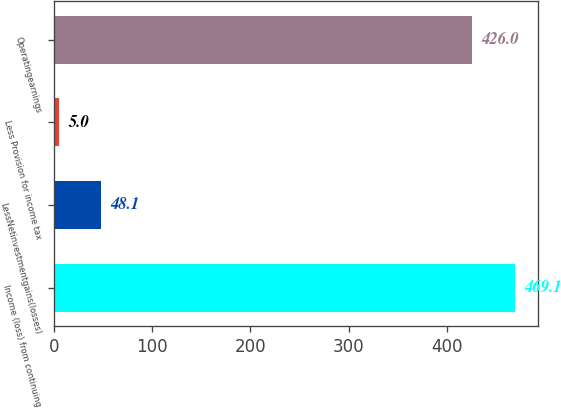Convert chart. <chart><loc_0><loc_0><loc_500><loc_500><bar_chart><fcel>Income (loss) from continuing<fcel>LessNetinvestmentgains(losses)<fcel>Less Provision for income tax<fcel>Operatingearnings<nl><fcel>469.1<fcel>48.1<fcel>5<fcel>426<nl></chart> 